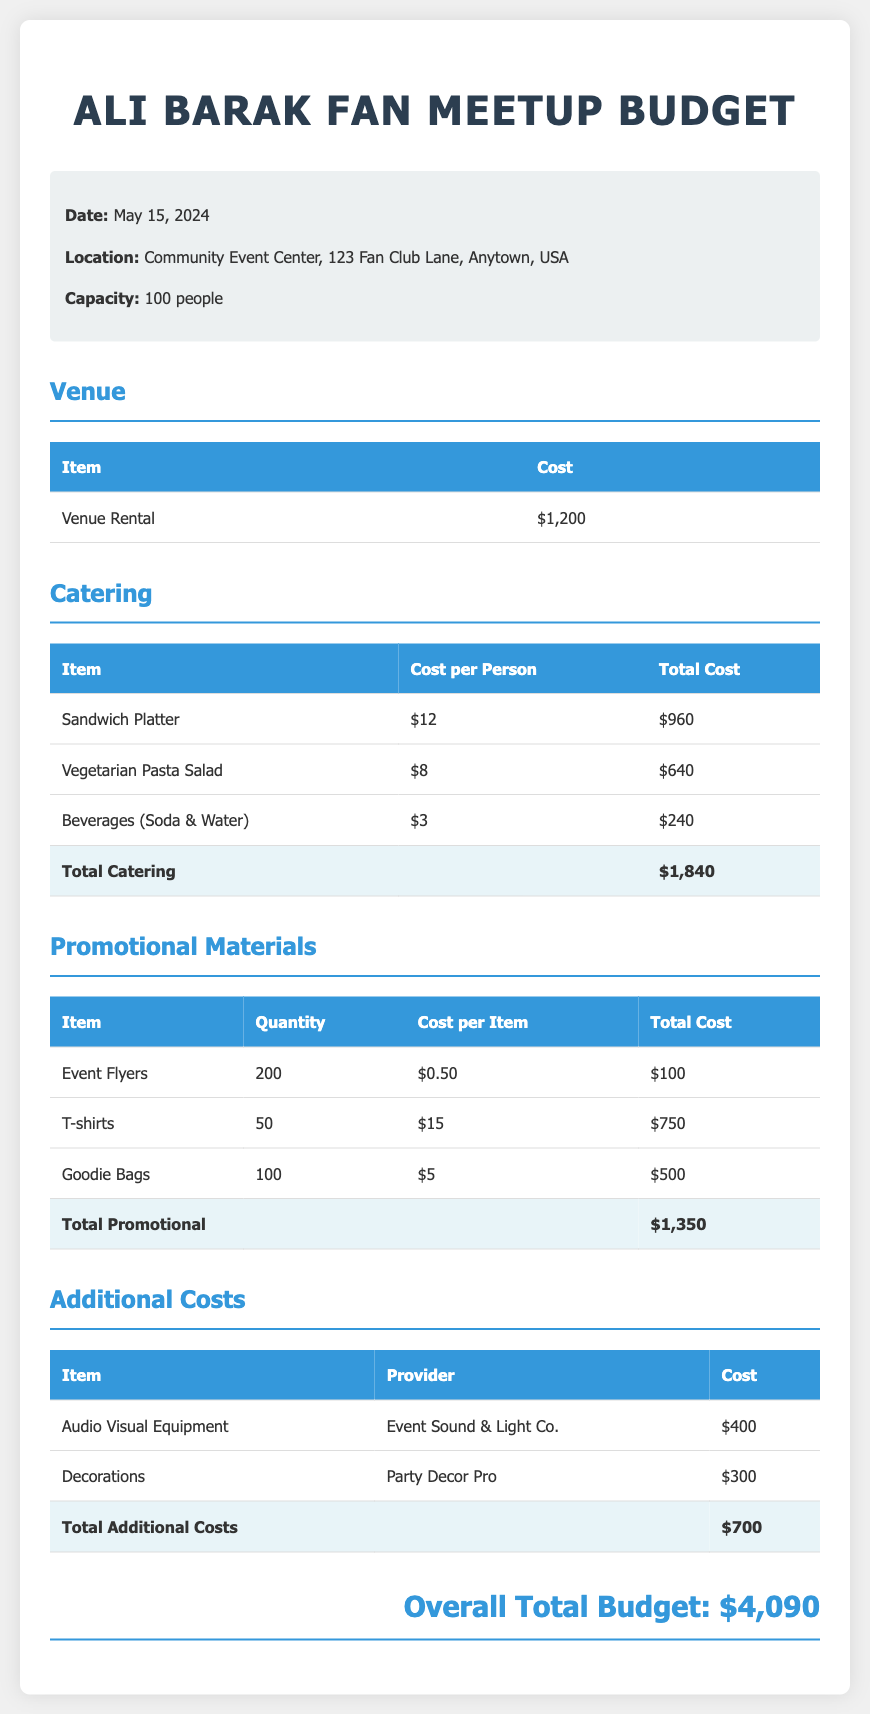what is the venue rental cost? The venue rental cost is specified in the budget under the venue section.
Answer: $1,200 how many people can attend the meetup? The capacity for the meetup is provided in the event information section.
Answer: 100 people what is the total cost for catering? The total cost for catering is found in the catering section, summing up all catering expenses.
Answer: $1,840 how many T-shirts are being ordered? The quantity of T-shirts is shown in the promotional materials section of the budget.
Answer: 50 who is providing the audio visual equipment? The provider for the audio visual equipment is listed under the additional costs section.
Answer: Event Sound & Light Co what is the overall total budget? The overall total budget is presented at the end of the document.
Answer: $4,090 what type of event is this budget for? The type of event is inferred from the title of the document.
Answer: Fan Meetup what is the cost per person for beverages? The cost per person for beverages is indicated in the catering table.
Answer: $3 how much are goodie bags in total? The total cost for goodie bags is detailed in the promotional materials section.
Answer: $500 